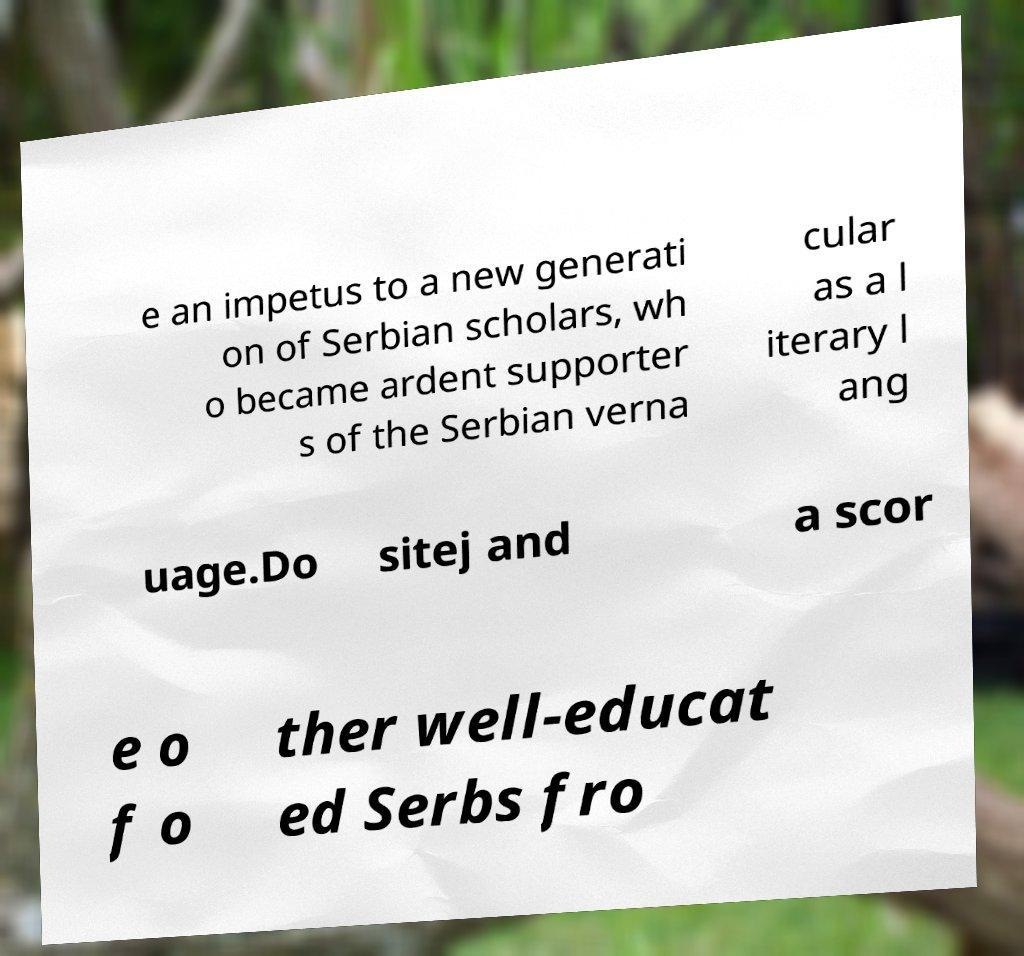Please read and relay the text visible in this image. What does it say? e an impetus to a new generati on of Serbian scholars, wh o became ardent supporter s of the Serbian verna cular as a l iterary l ang uage.Do sitej and a scor e o f o ther well-educat ed Serbs fro 